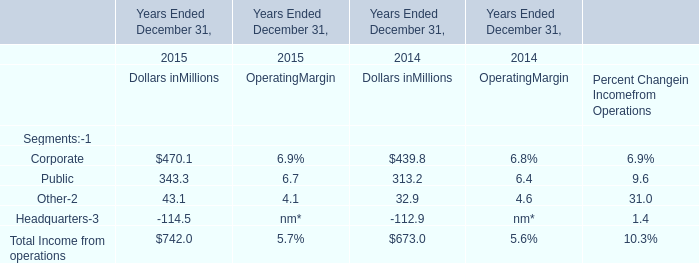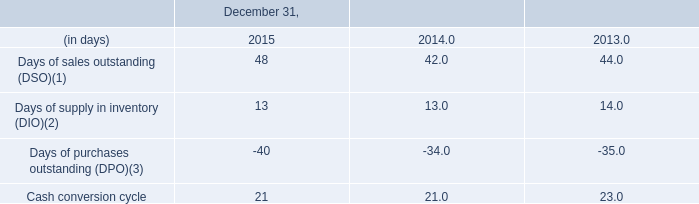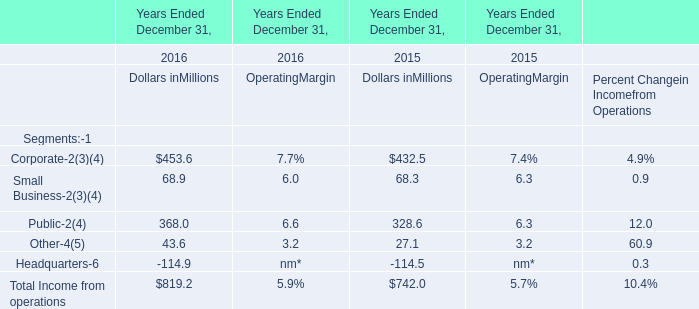Which year is Total Income from operations for section Dollars in Millions the highest? 
Answer: 2015. 